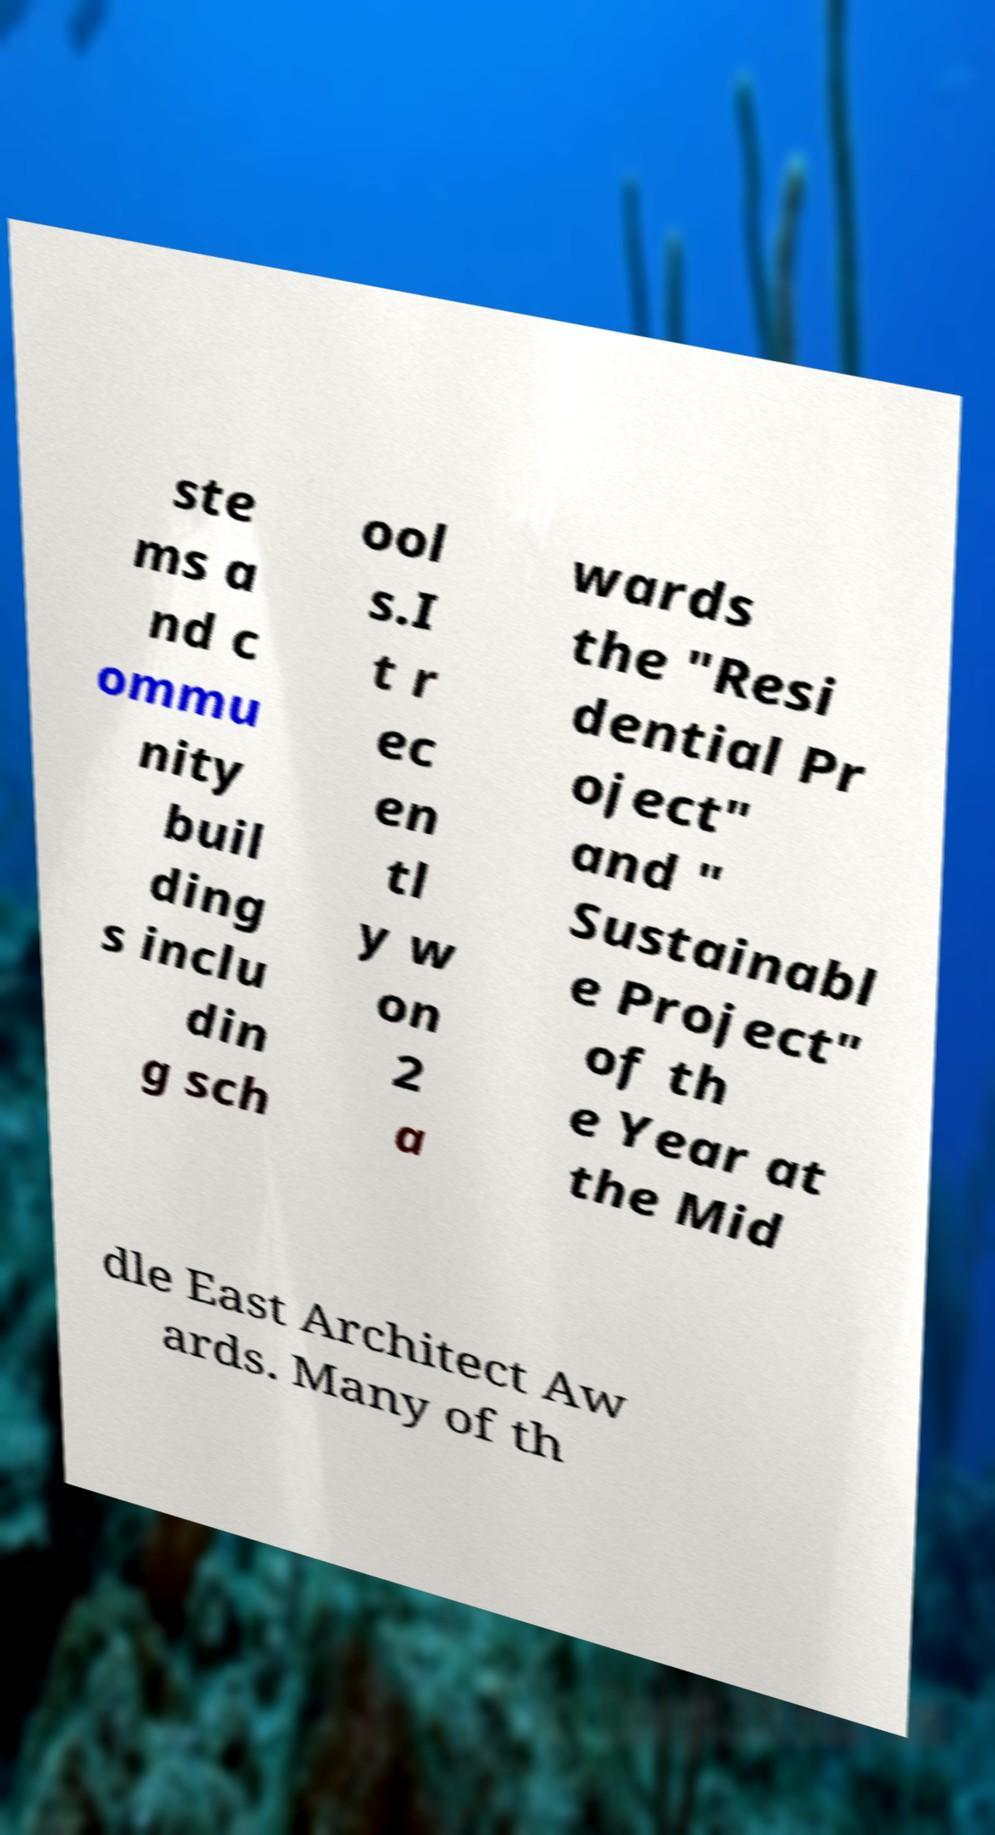I need the written content from this picture converted into text. Can you do that? ste ms a nd c ommu nity buil ding s inclu din g sch ool s.I t r ec en tl y w on 2 a wards the "Resi dential Pr oject" and " Sustainabl e Project" of th e Year at the Mid dle East Architect Aw ards. Many of th 